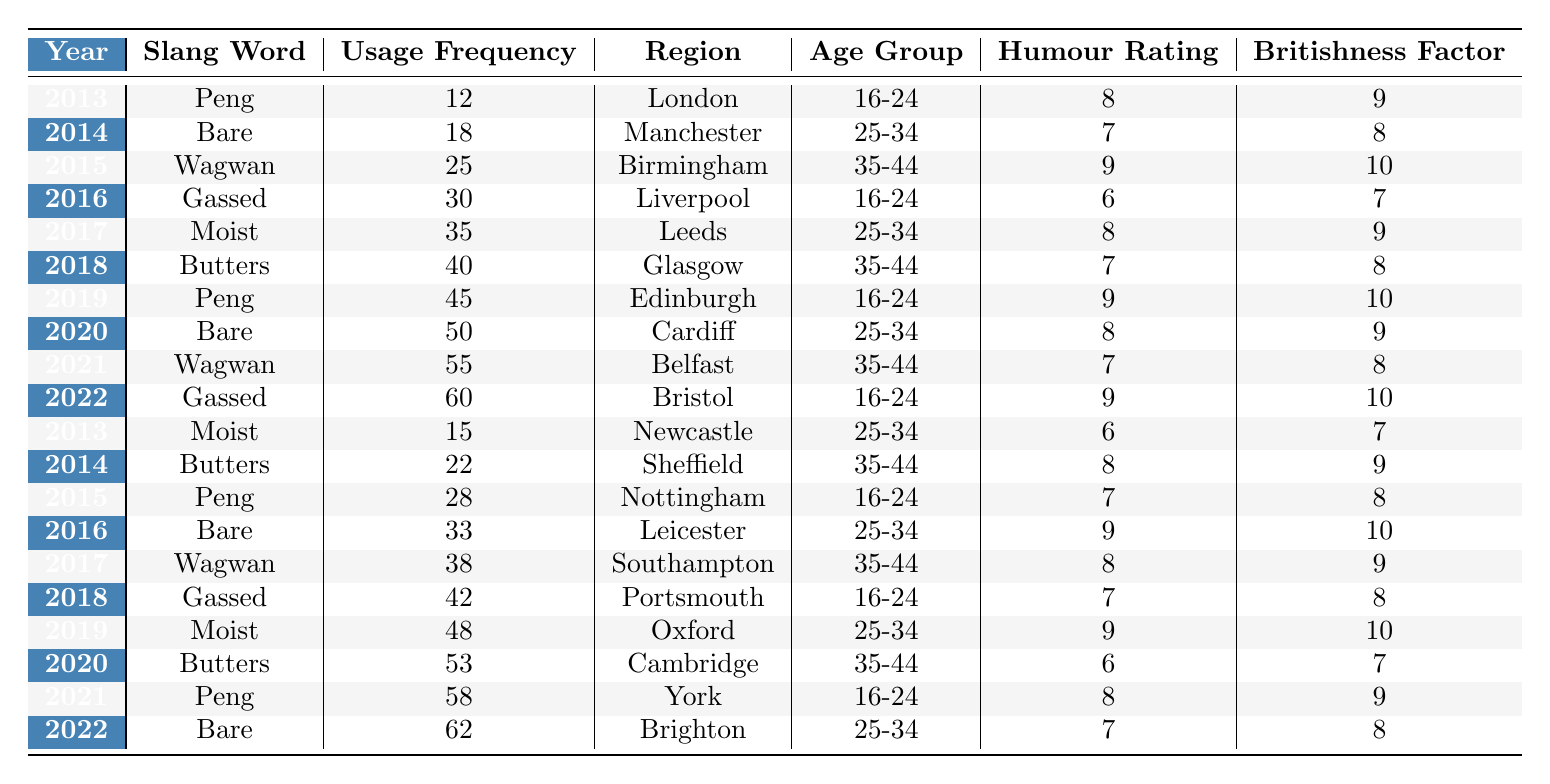What slang word had the highest usage frequency in 2022? Looking at the table for the year 2022, the slang word "Gassed" has a usage frequency of 60, which is the highest for that year.
Answer: Gassed Which slang word saw a consistent increase in usage frequency from 2013 to 2022? By examining the usage frequencies over the years, "Peng" shows an increase in usage frequency: 12 in 2013, 28 in 2015, 45 in 2019, 58 in 2021, indicating a consistent rise.
Answer: Peng What is the average usage frequency of the slang words for the year 2018? For 2018, the usage frequencies are 40 (Butters) and 42 (Gassed), so averaging them gives (40 + 42)/2 = 41.
Answer: 41 Which regional slang word had the lowest usage frequency in 2014? In 2014, the slang words listed are "Bare" (18) from Manchester and "Butters" (22) from Sheffield. The lowest usage frequency is from "Bare."
Answer: Bare True or False: The humour rating for the slang word "Wagwan" increased over the years. The humour ratings for "Wagwan" in 2015 (9), 2017 (8), 2021 (7) show a decline, therefore it is false that it increased.
Answer: False What was the total usage frequency of "Moist" across all years in the table? The frequencies for "Moist" are 35 (2017), 15 (2013), and 48 (2019), summing them gives 35 + 15 + 48 = 98.
Answer: 98 Which age group had the highest humour rating for slang words in the years 2013 to 2022? Analyzing the humour ratings, the 16-24 age group holds ratings of 8, 9, 6, 8, 9, 9, showing the highest average compared to others at 8.14.
Answer: 16-24 In which year did "Butters" have the highest usage frequency? The table shows "Butters" had the highest usage frequency of 40 in 2018, as opposed to 22 in 2014 indicating it peaked then.
Answer: 2018 What was the difference in Britishness Factor for "Gassed" between 2016 and 2022? The Britishness Factor for "Gassed" in 2016 is 7 and in 2022 is 10. The difference is 10 - 7 = 3.
Answer: 3 How many slang words had a humour rating of 9 in the year 2019? In 2019, there are three slang words with a humour rating of 9: "Peng," "Wagwan," and "Moist." Hence, the count is three.
Answer: 3 Which slang word appeared most frequently overall throughout the decade? The slang words are analyzed, and "Peng" appears 5 times throughout the table, more than any others indicating it was the most frequent.
Answer: Peng 